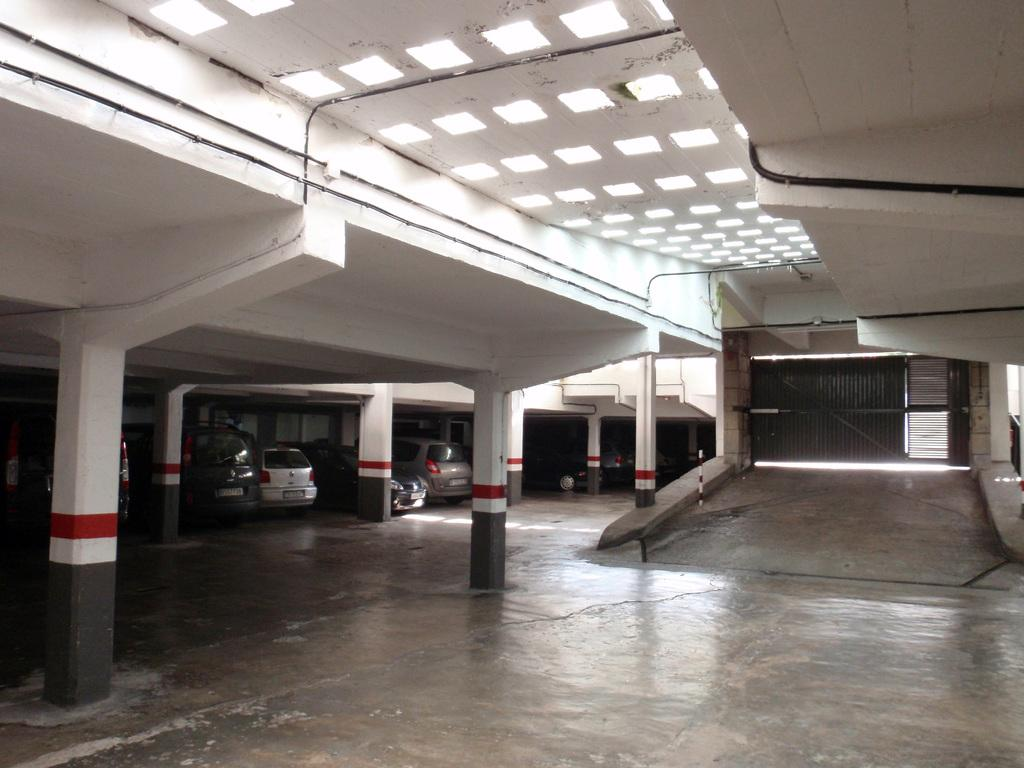What structure can be seen in the image? There is a gate in the image. What architectural elements support the gate? There are pillars in the image. What illuminates the area in the image? There are lights in the image. What else can be seen in the image besides the gate, pillars, and lights? There are some objects in the image. What can be seen in the background of the image? There are vehicles visible in the background of the image. What type of shade can be seen covering the plantation in the image? There is no shade or plantation present in the image; it features a gate, pillars, lights, objects, and vehicles. 